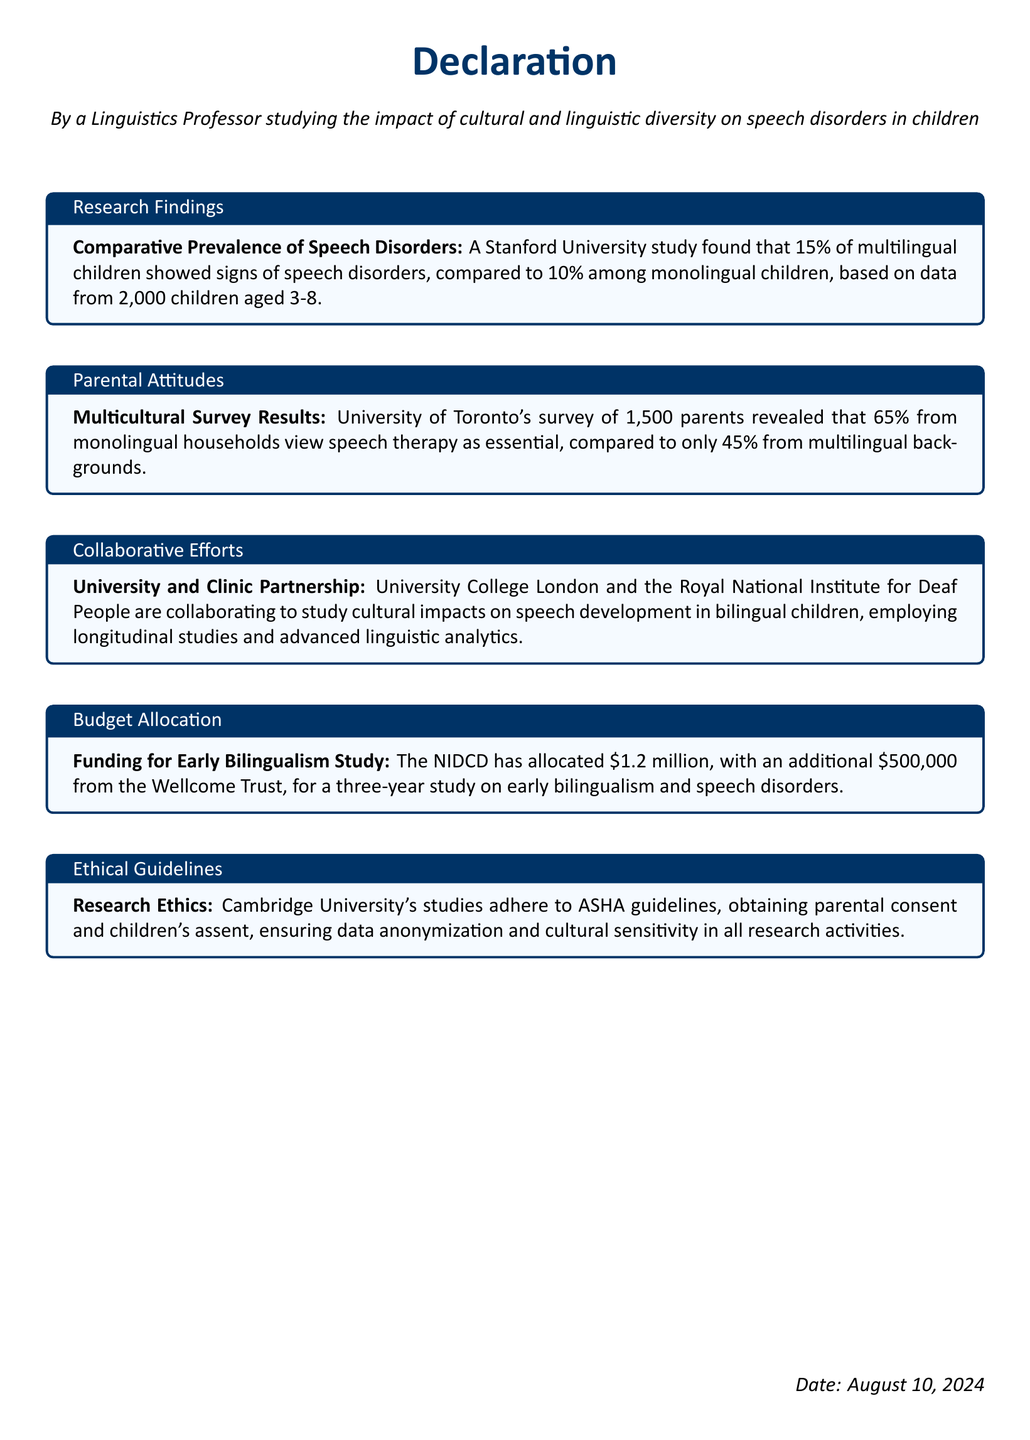What is the percentage of multilingual children with speech disorders? The document states that 15% of multilingual children showed signs of speech disorders, based on a study.
Answer: 15% What university conducted the study on comparative prevalence of speech disorders? The document mentions that a Stanford University study was performed.
Answer: Stanford University How many parents participated in the multicultural survey? The document indicates that 1,500 parents were surveyed at the University of Toronto.
Answer: 1,500 What is the additional funding received from the Wellcome Trust? The document specifies that \$500,000 was provided by the Wellcome Trust for the study.
Answer: \$500,000 What percentage of monolingual parents view speech therapy as essential? According to the document, 65% of monolingual parents consider speech therapy essential.
Answer: 65% Which two institutions are collaborating on research related to bilingual children? The document states that University College London and the Royal National Institute for Deaf People are collaborating.
Answer: University College London and the Royal National Institute for Deaf People What is the total funding allocated for the early bilingualism study? The document adds up the resources from the NIDCD and Wellcome Trust, totaling \$1.7 million.
Answer: \$1.7 million What ethical guidelines are the studies adhering to? The document mentions adherence to ASHA guidelines.
Answer: ASHA guidelines How long is the study on early bilingualism and speech disorders planned to last? The document states that the study is planned for three years.
Answer: three years 